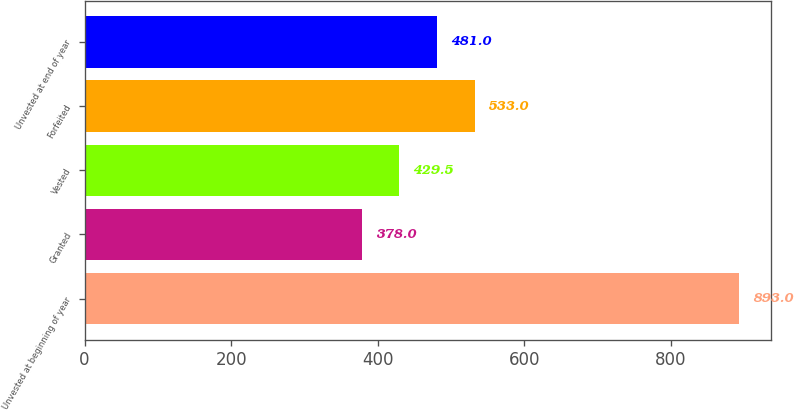Convert chart. <chart><loc_0><loc_0><loc_500><loc_500><bar_chart><fcel>Unvested at beginning of year<fcel>Granted<fcel>Vested<fcel>Forfeited<fcel>Unvested at end of year<nl><fcel>893<fcel>378<fcel>429.5<fcel>533<fcel>481<nl></chart> 